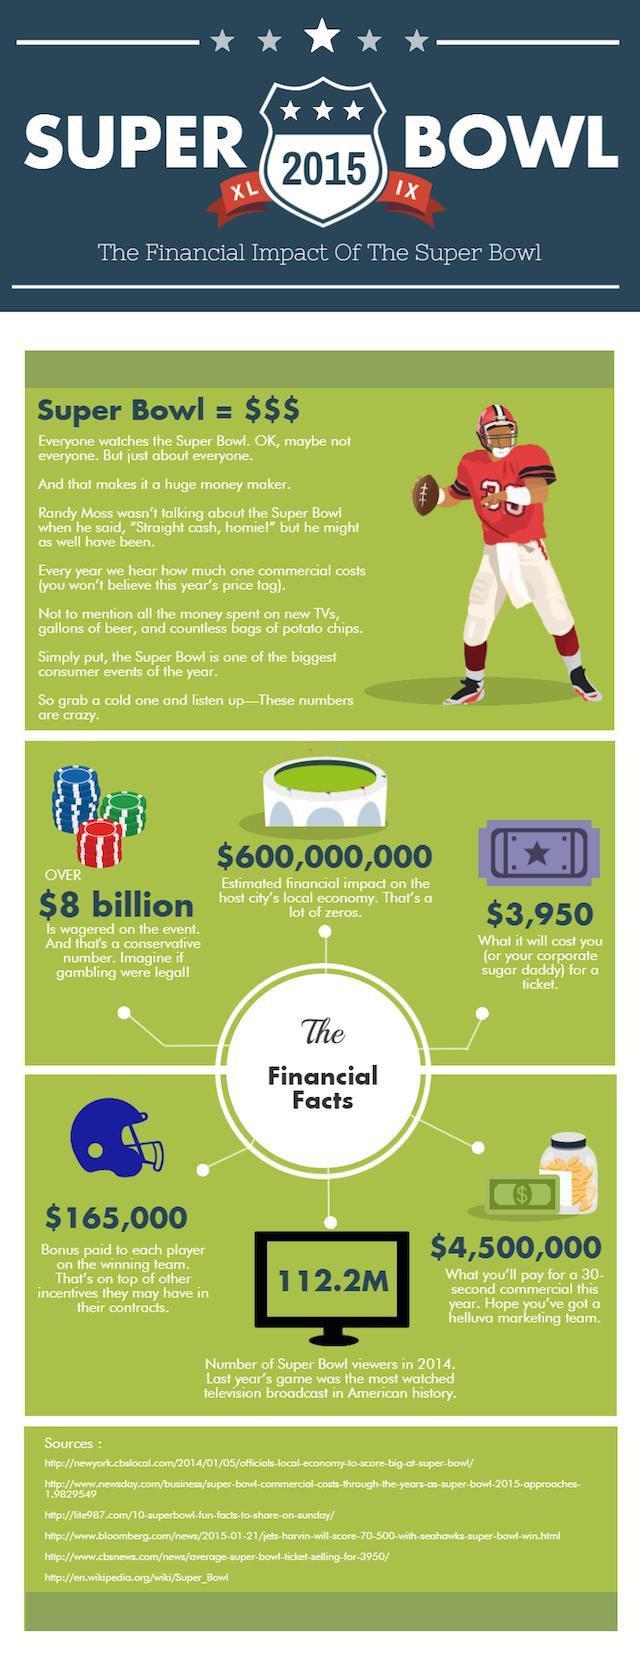Draw attention to some important aspects in this diagram. The Super Bowl events contribute approximately $600 million to the economy, which is significantly lower than the amounts previously reported, with the most recent estimate being $112.2 million. 